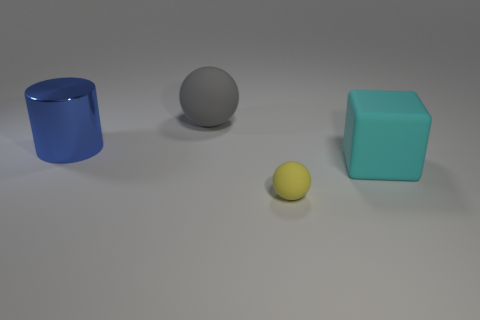Add 1 yellow spheres. How many objects exist? 5 Subtract all cylinders. How many objects are left? 3 Subtract 0 cyan balls. How many objects are left? 4 Subtract all purple metal things. Subtract all big gray matte balls. How many objects are left? 3 Add 3 blue metallic cylinders. How many blue metallic cylinders are left? 4 Add 1 blue things. How many blue things exist? 2 